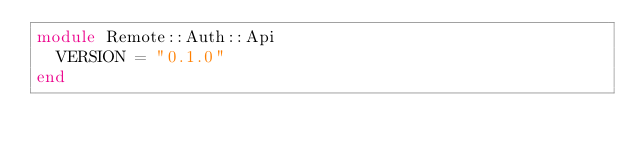Convert code to text. <code><loc_0><loc_0><loc_500><loc_500><_Crystal_>module Remote::Auth::Api
  VERSION = "0.1.0"
end
</code> 